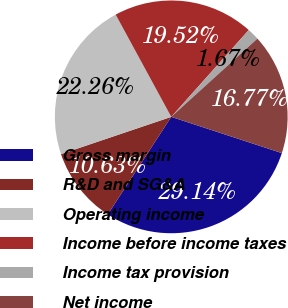<chart> <loc_0><loc_0><loc_500><loc_500><pie_chart><fcel>Gross margin<fcel>R&D and SG&A<fcel>Operating income<fcel>Income before income taxes<fcel>Income tax provision<fcel>Net income<nl><fcel>29.14%<fcel>10.63%<fcel>22.26%<fcel>19.52%<fcel>1.67%<fcel>16.77%<nl></chart> 